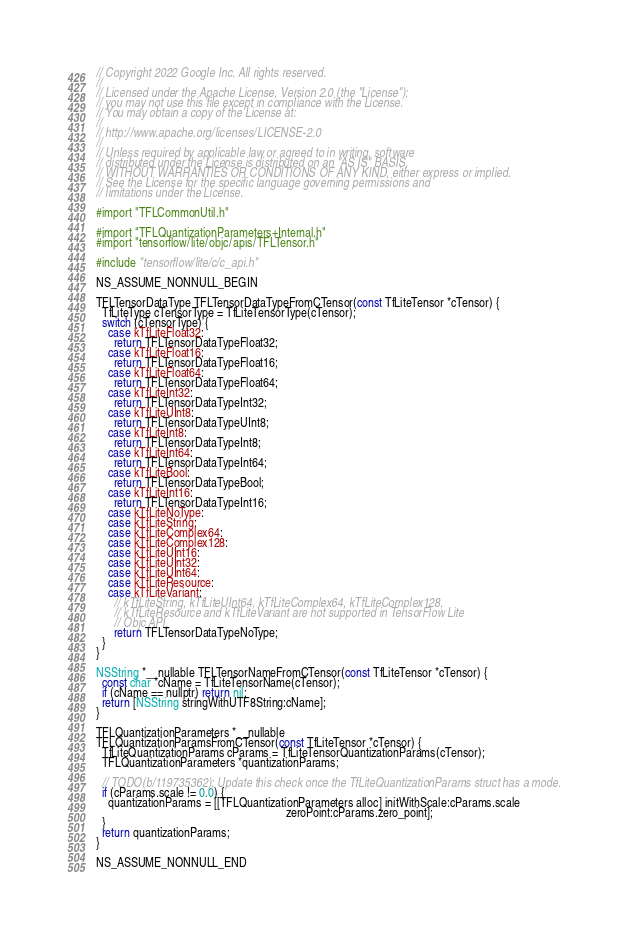<code> <loc_0><loc_0><loc_500><loc_500><_ObjectiveC_>// Copyright 2022 Google Inc. All rights reserved.
//
// Licensed under the Apache License, Version 2.0 (the "License");
// you may not use this file except in compliance with the License.
// You may obtain a copy of the License at:
//
// http://www.apache.org/licenses/LICENSE-2.0
//
// Unless required by applicable law or agreed to in writing, software
// distributed under the License is distributed on an "AS IS" BASIS,
// WITHOUT WARRANTIES OR CONDITIONS OF ANY KIND, either express or implied.
// See the License for the specific language governing permissions and
// limitations under the License.

#import "TFLCommonUtil.h"

#import "TFLQuantizationParameters+Internal.h"
#import "tensorflow/lite/objc/apis/TFLTensor.h"

#include "tensorflow/lite/c/c_api.h"

NS_ASSUME_NONNULL_BEGIN

TFLTensorDataType TFLTensorDataTypeFromCTensor(const TfLiteTensor *cTensor) {
  TfLiteType cTensorType = TfLiteTensorType(cTensor);
  switch (cTensorType) {
    case kTfLiteFloat32:
      return TFLTensorDataTypeFloat32;
    case kTfLiteFloat16:
      return TFLTensorDataTypeFloat16;
    case kTfLiteFloat64:
      return TFLTensorDataTypeFloat64;
    case kTfLiteInt32:
      return TFLTensorDataTypeInt32;
    case kTfLiteUInt8:
      return TFLTensorDataTypeUInt8;
    case kTfLiteInt8:
      return TFLTensorDataTypeInt8;
    case kTfLiteInt64:
      return TFLTensorDataTypeInt64;
    case kTfLiteBool:
      return TFLTensorDataTypeBool;
    case kTfLiteInt16:
      return TFLTensorDataTypeInt16;
    case kTfLiteNoType:
    case kTfLiteString:
    case kTfLiteComplex64:
    case kTfLiteComplex128:
    case kTfLiteUInt16:
    case kTfLiteUInt32:
    case kTfLiteUInt64:
    case kTfLiteResource:
    case kTfLiteVariant:
      // kTfLiteString, kTfLiteUInt64, kTfLiteComplex64, kTfLiteComplex128,
      // kTfLiteResource and kTfLiteVariant are not supported in TensorFlow Lite
      // Objc API.
      return TFLTensorDataTypeNoType;
  }
}

NSString *__nullable TFLTensorNameFromCTensor(const TfLiteTensor *cTensor) {
  const char *cName = TfLiteTensorName(cTensor);
  if (cName == nullptr) return nil;
  return [NSString stringWithUTF8String:cName];
}

TFLQuantizationParameters *__nullable
TFLQuantizationParamsFromCTensor(const TfLiteTensor *cTensor) {
  TfLiteQuantizationParams cParams = TfLiteTensorQuantizationParams(cTensor);
  TFLQuantizationParameters *quantizationParams;

  // TODO(b/119735362): Update this check once the TfLiteQuantizationParams struct has a mode.
  if (cParams.scale != 0.0) {
    quantizationParams = [[TFLQuantizationParameters alloc] initWithScale:cParams.scale
                                                                zeroPoint:cParams.zero_point];
  }
  return quantizationParams;
}

NS_ASSUME_NONNULL_END
</code> 